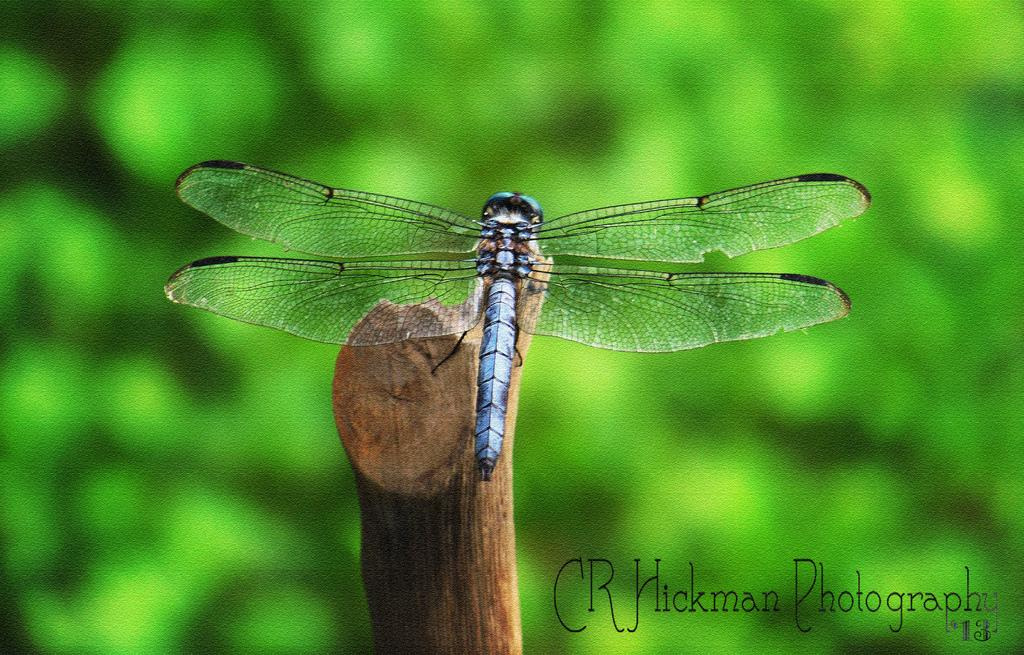What type of insect is in the image? There is a dragonfly in the image. What is the dragonfly resting on? The dragonfly is on a wooden stick. What type of cheese is being used as a toothbrush in the image? There is no cheese or toothbrush present in the image; it features a dragonfly on a wooden stick. 